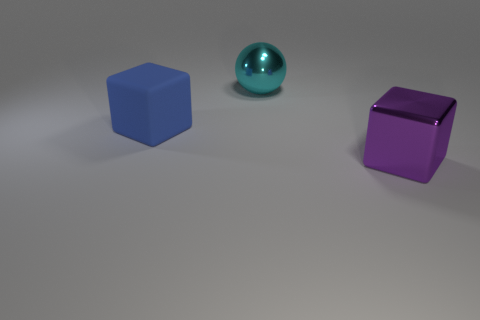Add 1 rubber things. How many objects exist? 4 Subtract all cubes. How many objects are left? 1 Add 1 cyan shiny things. How many cyan shiny things are left? 2 Add 2 tiny red metallic cylinders. How many tiny red metallic cylinders exist? 2 Subtract 0 blue cylinders. How many objects are left? 3 Subtract all big cubes. Subtract all tiny brown cylinders. How many objects are left? 1 